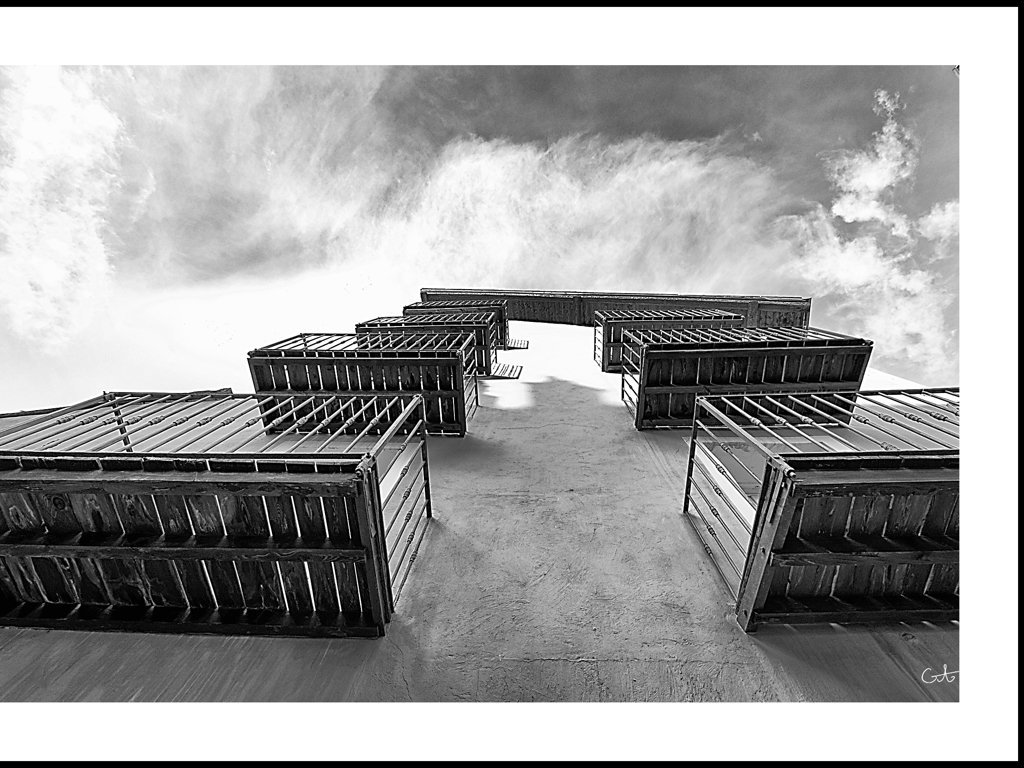What does the composition of this image convey to the viewer? The composition, leveraging a low angle perspective, portrays the building as towering and formidable. The convergence of lines draws the viewer’s eye upward, imparting a sense of height and grandeur, while the monochromatic color palette emphasizes the textures and patterns. 